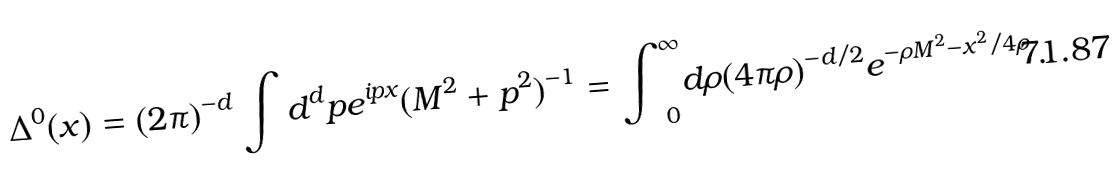Convert formula to latex. <formula><loc_0><loc_0><loc_500><loc_500>\Delta ^ { 0 } ( x ) = ( 2 \pi ) ^ { - d } \int { d } ^ { d } p e ^ { i p x } ( M ^ { 2 } + p ^ { 2 } ) ^ { - 1 } = { \int } _ { \, 0 } ^ { \infty } d \rho ( 4 \pi \rho ) ^ { - d / 2 } e ^ { - \rho M ^ { 2 } - x ^ { 2 } / { 4 \rho } } \, .</formula> 